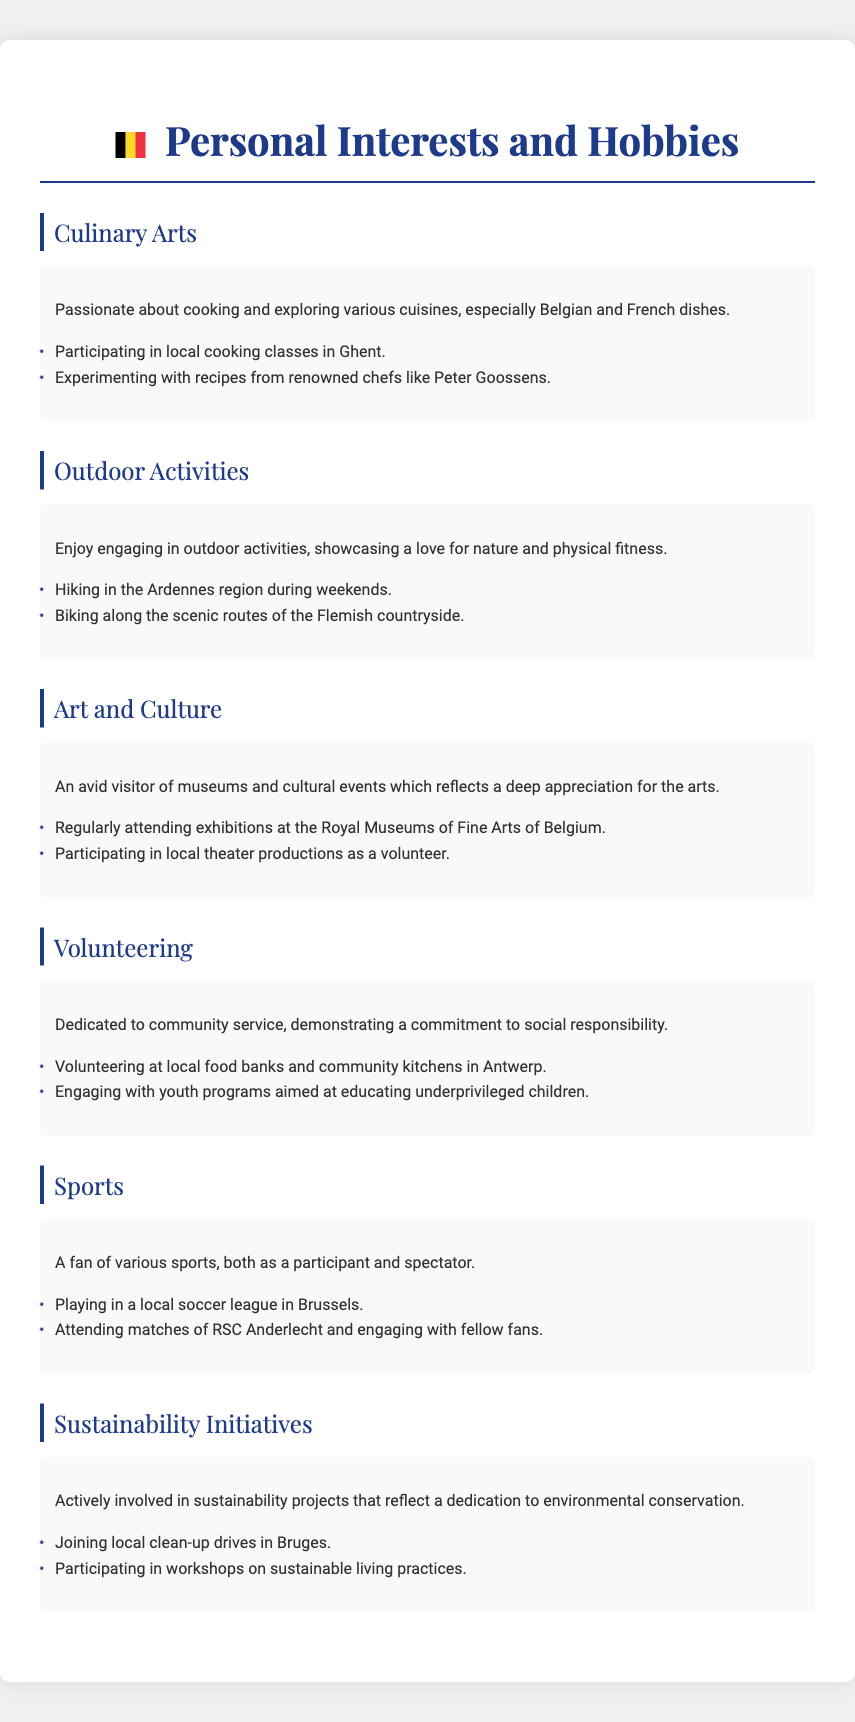What is the main culinary interest mentioned? The document mentions a passion for cooking and exploring various cuisines, especially Belgian and French dishes.
Answer: Belgian and French dishes Where does the individual participate in cooking classes? The document states that the individual participates in local cooking classes in a specific city in Belgium.
Answer: Ghent What outdoor activity is enjoyed on weekends? The document indicates that a specific outdoor activity is engaged in during weekends.
Answer: Hiking Which sports team does the individual attend matches for? According to the document, the individual engages with fellow fans of a specific sports team mentioned.
Answer: RSC Anderlecht What type of community service is emphasized? The document highlights a specific commitment to a type of community service related to social responsibility.
Answer: Volunteering Which region is preferred for biking activities? The document specifies a scenic location for biking activities mentioned in the content.
Answer: Flemish countryside How does the individual contribute to sustainability initiatives? The document describes specific activities that the individual participates in to support sustainability.
Answer: Clean-up drives What is the individual's involvement in the arts? The document states that the individual regularly attends exhibitions related to a particular cultural institution.
Answer: Royal Museums of Fine Arts of Belgium Which theater activity does the individual participate in? The document mentions a specific activity related to theater that the individual volunteers for.
Answer: Local theater productions 